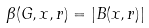<formula> <loc_0><loc_0><loc_500><loc_500>\beta ( G , x , r ) = | B ( x , r ) |</formula> 